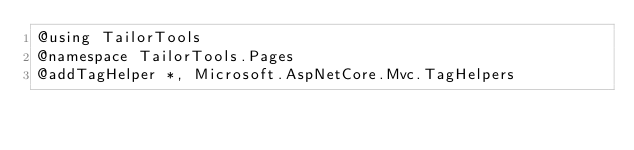Convert code to text. <code><loc_0><loc_0><loc_500><loc_500><_C#_>@using TailorTools
@namespace TailorTools.Pages
@addTagHelper *, Microsoft.AspNetCore.Mvc.TagHelpers
</code> 